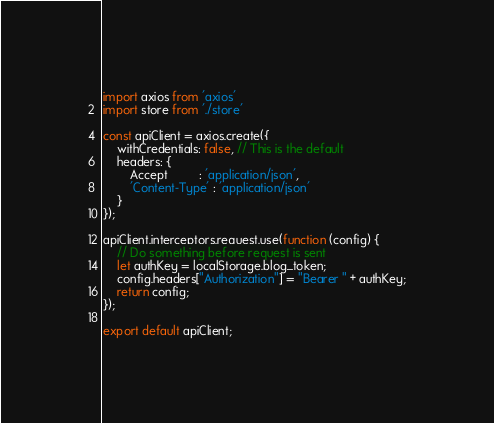Convert code to text. <code><loc_0><loc_0><loc_500><loc_500><_JavaScript_>import axios from 'axios'
import store from './store'

const apiClient = axios.create({
    withCredentials: false, // This is the default
    headers: {
        Accept         : 'application/json',
        'Content-Type' : 'application/json'
    }
});

apiClient.interceptors.request.use(function (config) {
    // Do something before request is sent
    let authKey = localStorage.blog_token;
    config.headers["Authorization"] = "Bearer " + authKey;
    return config;
});

export default apiClient;
</code> 